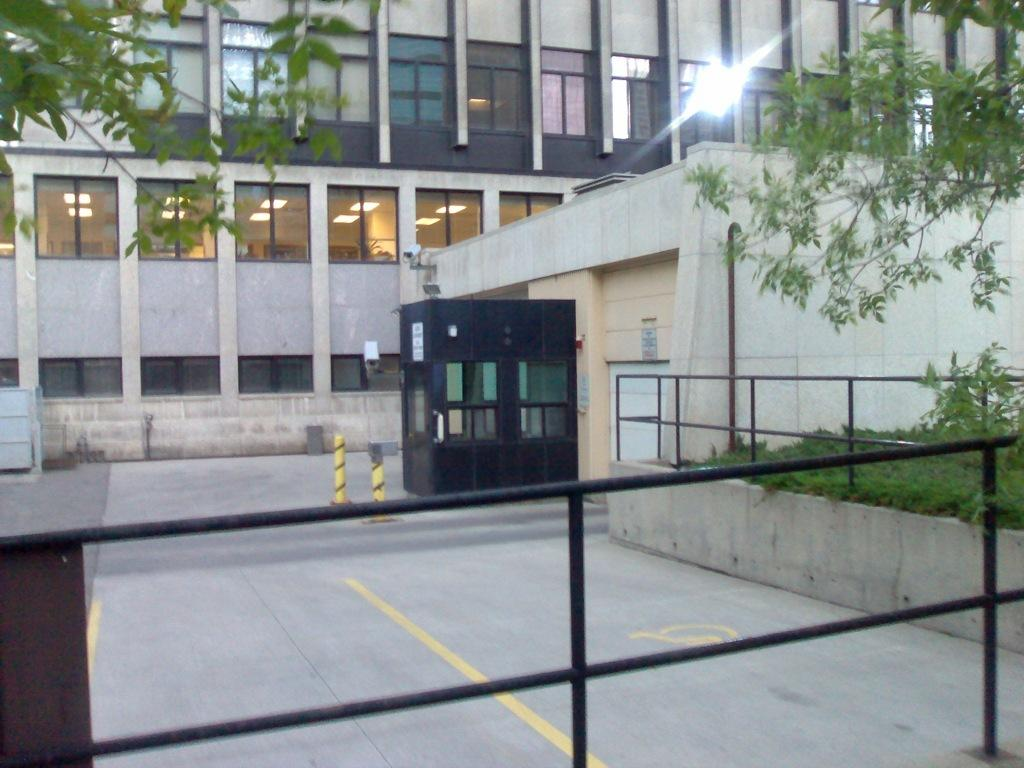What type of structures are visible in the image? There are buildings with windows in the image. What can be found inside the buildings? There are ceiling lights in the buildings. What type of barrier is present in the image? There is a metal fence in the image. What are the vertical structures in the image? There are poles in the image. What type of vegetation is present in the image? There are plants and trees in the image. What type of card is being used to care for the plants in the image? There is no card or care for plants mentioned or visible in the image. How many fingers can be seen interacting with the trees in the image? There are no fingers or direct interaction with the trees visible in the image. 